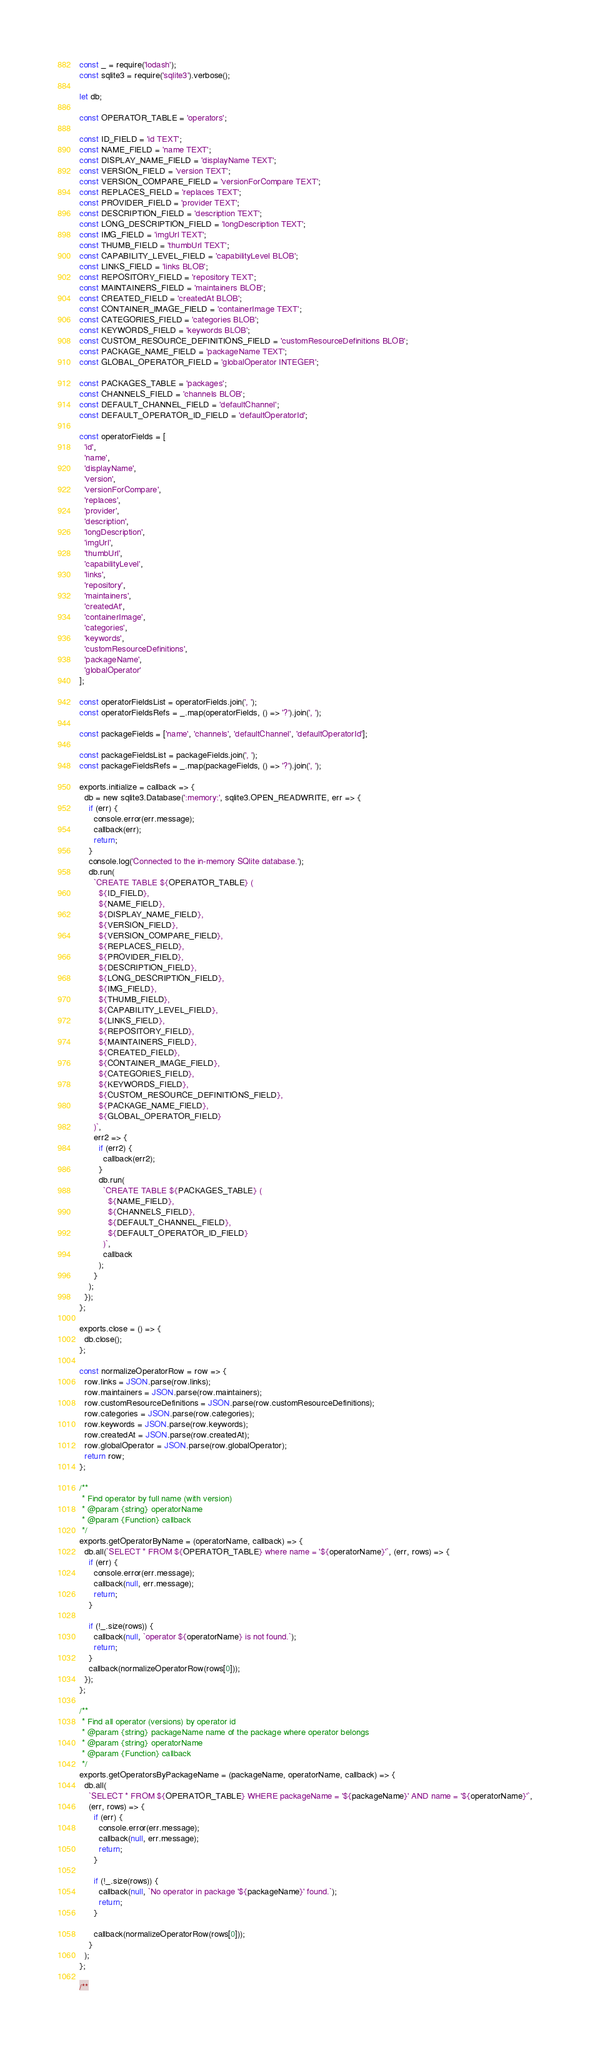<code> <loc_0><loc_0><loc_500><loc_500><_JavaScript_>const _ = require('lodash');
const sqlite3 = require('sqlite3').verbose();

let db;

const OPERATOR_TABLE = 'operators';

const ID_FIELD = 'id TEXT';
const NAME_FIELD = 'name TEXT';
const DISPLAY_NAME_FIELD = 'displayName TEXT';
const VERSION_FIELD = 'version TEXT';
const VERSION_COMPARE_FIELD = 'versionForCompare TEXT';
const REPLACES_FIELD = 'replaces TEXT';
const PROVIDER_FIELD = 'provider TEXT';
const DESCRIPTION_FIELD = 'description TEXT';
const LONG_DESCRIPTION_FIELD = 'longDescription TEXT';
const IMG_FIELD = 'imgUrl TEXT';
const THUMB_FIELD = 'thumbUrl TEXT';
const CAPABILITY_LEVEL_FIELD = 'capabilityLevel BLOB';
const LINKS_FIELD = 'links BLOB';
const REPOSITORY_FIELD = 'repository TEXT';
const MAINTAINERS_FIELD = 'maintainers BLOB';
const CREATED_FIELD = 'createdAt BLOB';
const CONTAINER_IMAGE_FIELD = 'containerImage TEXT';
const CATEGORIES_FIELD = 'categories BLOB';
const KEYWORDS_FIELD = 'keywords BLOB';
const CUSTOM_RESOURCE_DEFINITIONS_FIELD = 'customResourceDefinitions BLOB';
const PACKAGE_NAME_FIELD = 'packageName TEXT';
const GLOBAL_OPERATOR_FIELD = 'globalOperator INTEGER';

const PACKAGES_TABLE = 'packages';
const CHANNELS_FIELD = 'channels BLOB';
const DEFAULT_CHANNEL_FIELD = 'defaultChannel';
const DEFAULT_OPERATOR_ID_FIELD = 'defaultOperatorId';

const operatorFields = [
  'id',
  'name',
  'displayName',
  'version',
  'versionForCompare',
  'replaces',
  'provider',
  'description',
  'longDescription',
  'imgUrl',
  'thumbUrl',
  'capabilityLevel',
  'links',
  'repository',
  'maintainers',
  'createdAt',
  'containerImage',
  'categories',
  'keywords',
  'customResourceDefinitions',
  'packageName',
  'globalOperator'
];

const operatorFieldsList = operatorFields.join(', ');
const operatorFieldsRefs = _.map(operatorFields, () => '?').join(', ');

const packageFields = ['name', 'channels', 'defaultChannel', 'defaultOperatorId'];

const packageFieldsList = packageFields.join(', ');
const packageFieldsRefs = _.map(packageFields, () => '?').join(', ');

exports.initialize = callback => {
  db = new sqlite3.Database(':memory:', sqlite3.OPEN_READWRITE, err => {
    if (err) {
      console.error(err.message);
      callback(err);
      return;
    }
    console.log('Connected to the in-memory SQlite database.');
    db.run(
      `CREATE TABLE ${OPERATOR_TABLE} (
        ${ID_FIELD},
        ${NAME_FIELD},
        ${DISPLAY_NAME_FIELD},
        ${VERSION_FIELD},
        ${VERSION_COMPARE_FIELD},
        ${REPLACES_FIELD},
        ${PROVIDER_FIELD},
        ${DESCRIPTION_FIELD},
        ${LONG_DESCRIPTION_FIELD},
        ${IMG_FIELD},
        ${THUMB_FIELD},
        ${CAPABILITY_LEVEL_FIELD},
        ${LINKS_FIELD},
        ${REPOSITORY_FIELD},
        ${MAINTAINERS_FIELD},
        ${CREATED_FIELD},
        ${CONTAINER_IMAGE_FIELD},
        ${CATEGORIES_FIELD},
        ${KEYWORDS_FIELD},
        ${CUSTOM_RESOURCE_DEFINITIONS_FIELD},
        ${PACKAGE_NAME_FIELD},
        ${GLOBAL_OPERATOR_FIELD}
      )`,
      err2 => {
        if (err2) {
          callback(err2);
        }
        db.run(
          `CREATE TABLE ${PACKAGES_TABLE} (
            ${NAME_FIELD},
            ${CHANNELS_FIELD},
            ${DEFAULT_CHANNEL_FIELD},
            ${DEFAULT_OPERATOR_ID_FIELD}
          )`,
          callback
        );
      }
    );
  });
};

exports.close = () => {
  db.close();
};

const normalizeOperatorRow = row => {
  row.links = JSON.parse(row.links);
  row.maintainers = JSON.parse(row.maintainers);
  row.customResourceDefinitions = JSON.parse(row.customResourceDefinitions);
  row.categories = JSON.parse(row.categories);
  row.keywords = JSON.parse(row.keywords);
  row.createdAt = JSON.parse(row.createdAt);
  row.globalOperator = JSON.parse(row.globalOperator);
  return row;
};

/**
 * Find operator by full name (with version)
 * @param {string} operatorName
 * @param {Function} callback
 */
exports.getOperatorByName = (operatorName, callback) => {
  db.all(`SELECT * FROM ${OPERATOR_TABLE} where name = '${operatorName}'`, (err, rows) => {
    if (err) {
      console.error(err.message);
      callback(null, err.message);
      return;
    }

    if (!_.size(rows)) {
      callback(null, `operator ${operatorName} is not found.`);
      return;
    }
    callback(normalizeOperatorRow(rows[0]));
  });
};

/**
 * Find all operator (versions) by operator id
 * @param {string} packageName name of the package where operator belongs
 * @param {string} operatorName
 * @param {Function} callback
 */
exports.getOperatorsByPackageName = (packageName, operatorName, callback) => {
  db.all(
    `SELECT * FROM ${OPERATOR_TABLE} WHERE packageName = '${packageName}' AND name = '${operatorName}'`,
    (err, rows) => {
      if (err) {
        console.error(err.message);
        callback(null, err.message);
        return;
      }

      if (!_.size(rows)) {
        callback(null, `No operator in package '${packageName}' found.`);
        return;
      }

      callback(normalizeOperatorRow(rows[0]));
    }
  );
};

/**</code> 